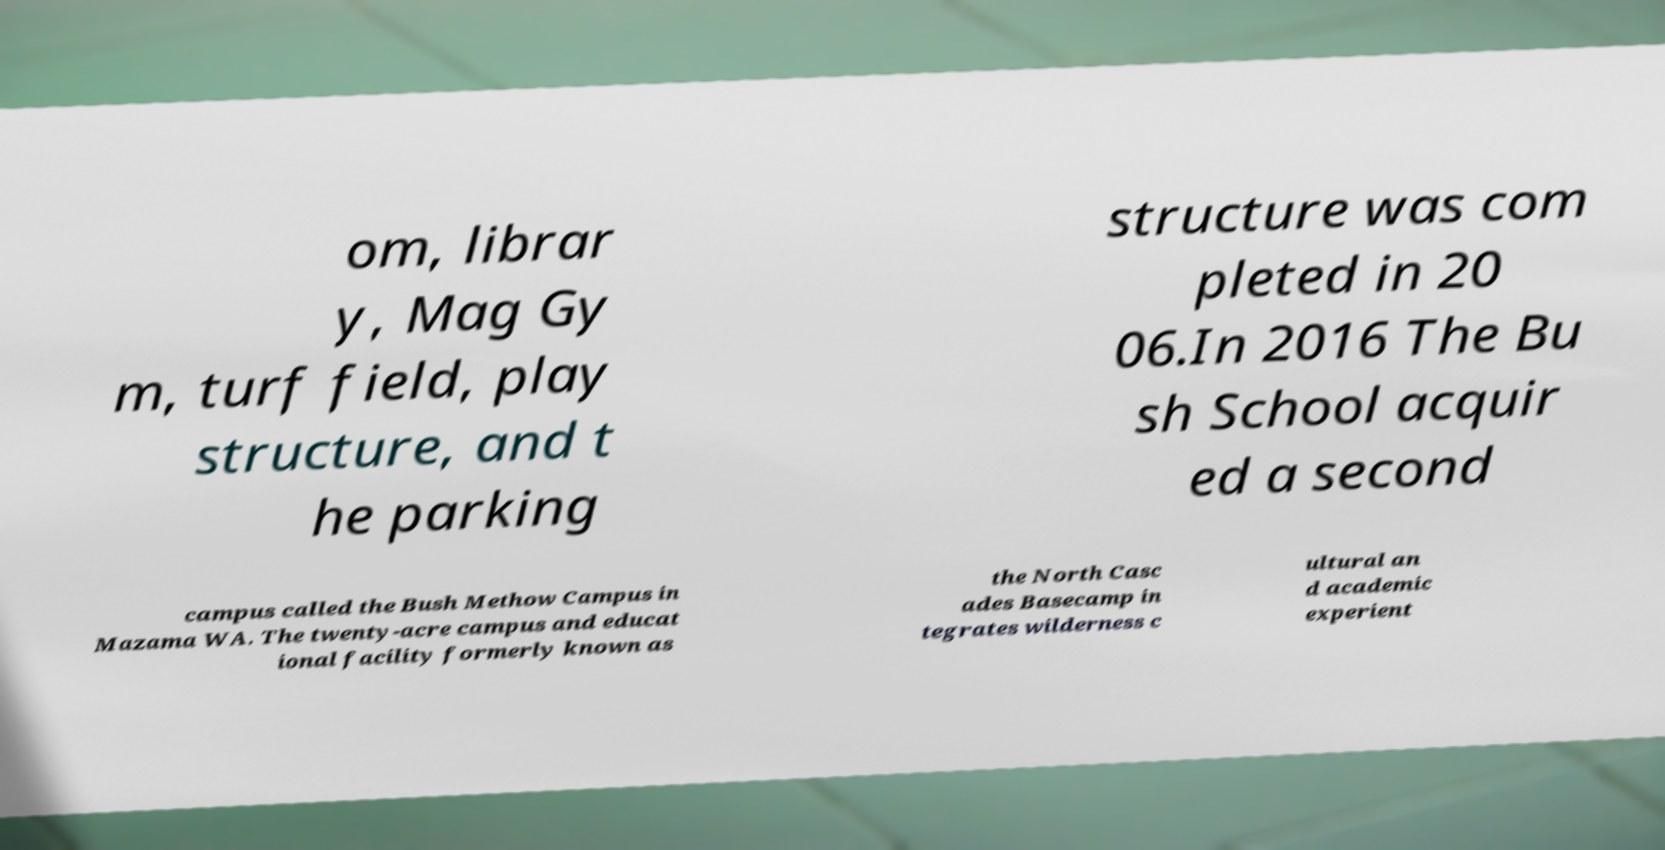Can you read and provide the text displayed in the image?This photo seems to have some interesting text. Can you extract and type it out for me? om, librar y, Mag Gy m, turf field, play structure, and t he parking structure was com pleted in 20 06.In 2016 The Bu sh School acquir ed a second campus called the Bush Methow Campus in Mazama WA. The twenty-acre campus and educat ional facility formerly known as the North Casc ades Basecamp in tegrates wilderness c ultural an d academic experient 